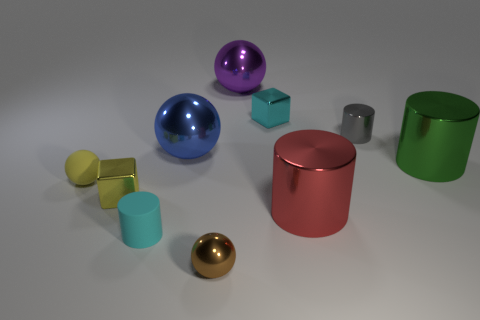What materials are the objects in the image made of? The objects in the image seem to be made of various metals, as suggested by their reflective surfaces and distinctive colors commonly associated with metallic materials. 